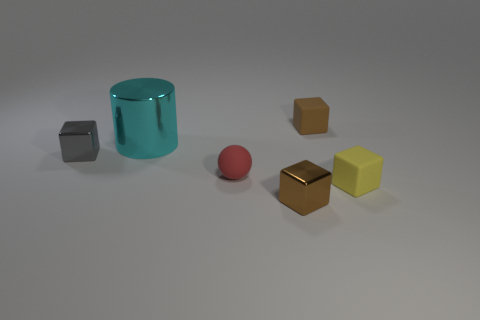Is the color of the small shiny block on the left side of the cylinder the same as the small block behind the cyan metallic thing?
Keep it short and to the point. No. Is there anything else that has the same color as the tiny ball?
Ensure brevity in your answer.  No. The large object has what color?
Give a very brief answer. Cyan. Are any big shiny things visible?
Provide a succinct answer. Yes. Are there any small blocks to the left of the large metal object?
Give a very brief answer. Yes. There is a tiny gray object that is the same shape as the tiny yellow rubber thing; what material is it?
Offer a terse response. Metal. Is there any other thing that has the same material as the yellow cube?
Provide a succinct answer. Yes. How many other objects are the same shape as the brown matte object?
Your answer should be compact. 3. How many small brown objects are behind the small rubber object that is left of the brown thing that is in front of the gray block?
Provide a succinct answer. 1. How many large cyan metal things are the same shape as the gray object?
Your response must be concise. 0. 